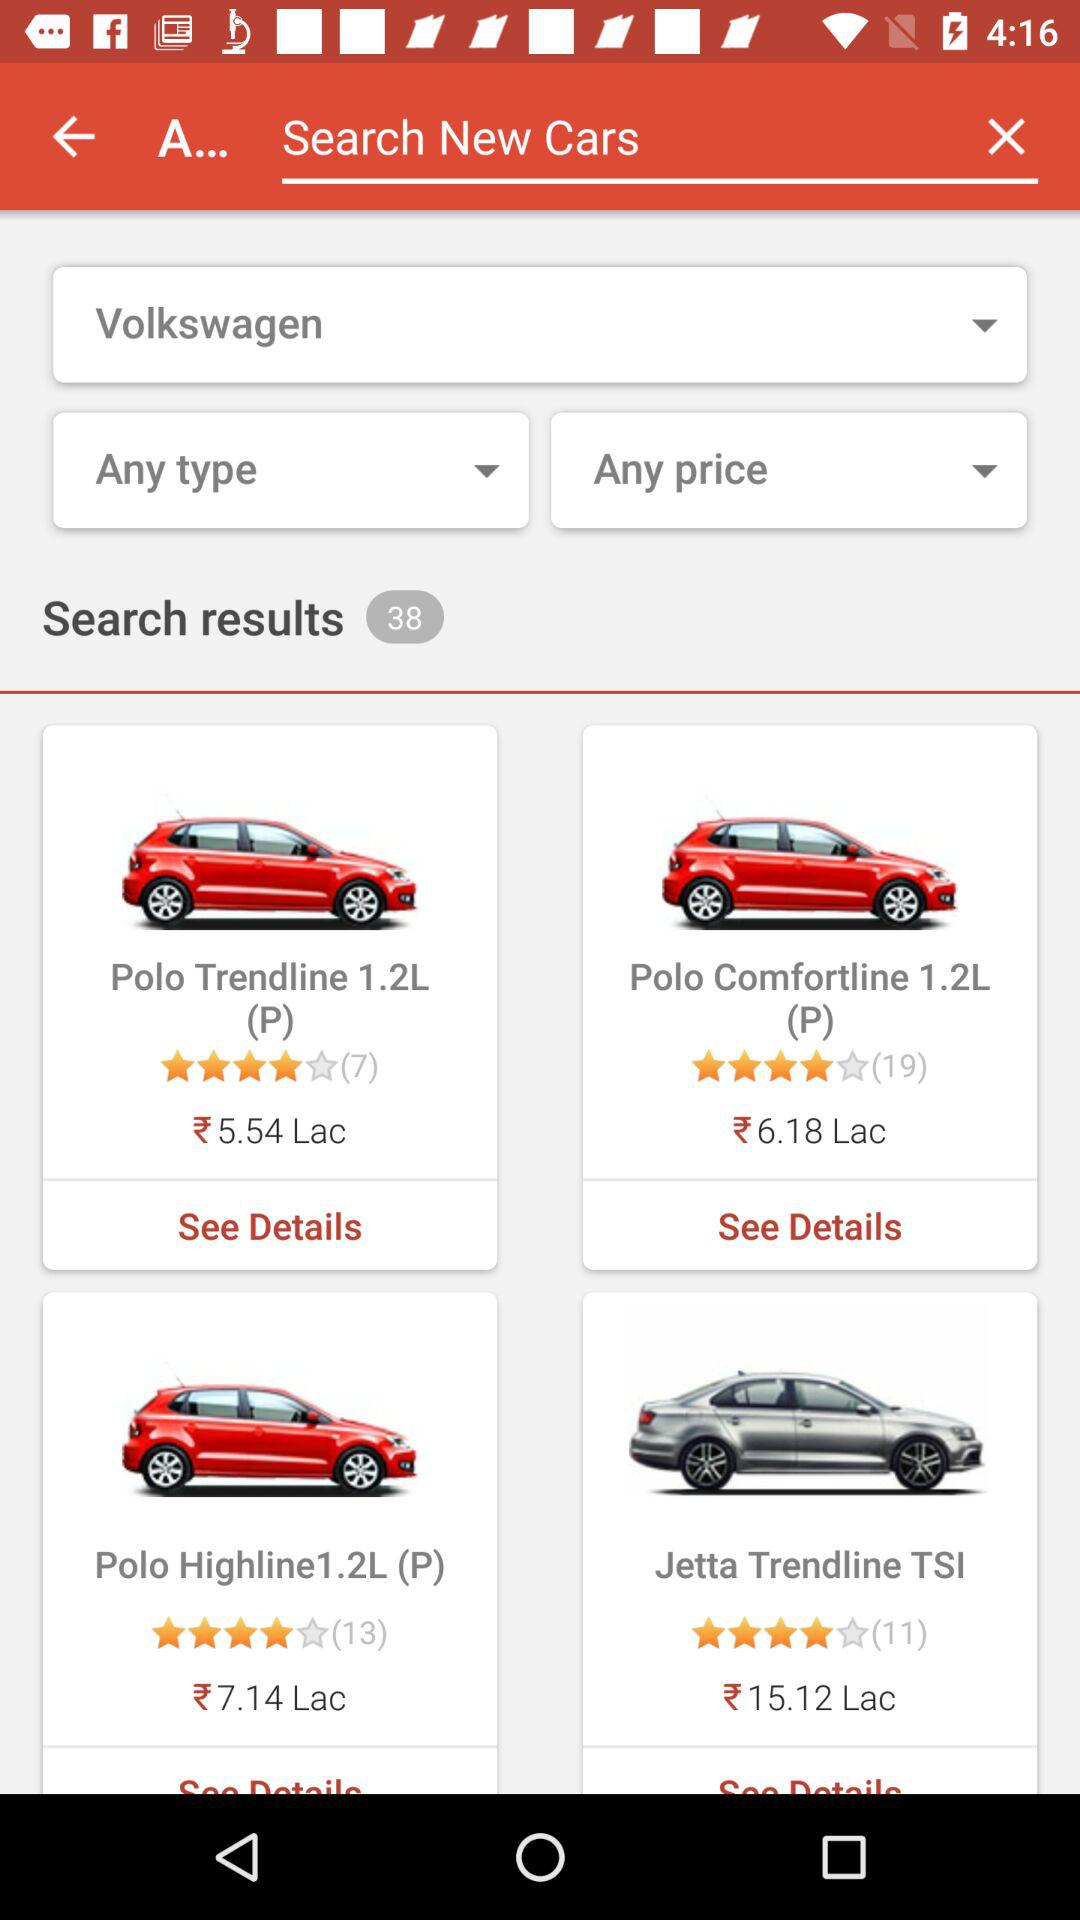What is the price of "Polo Trendline 1.2L"? The price is Rs. 5.54 lakh. 